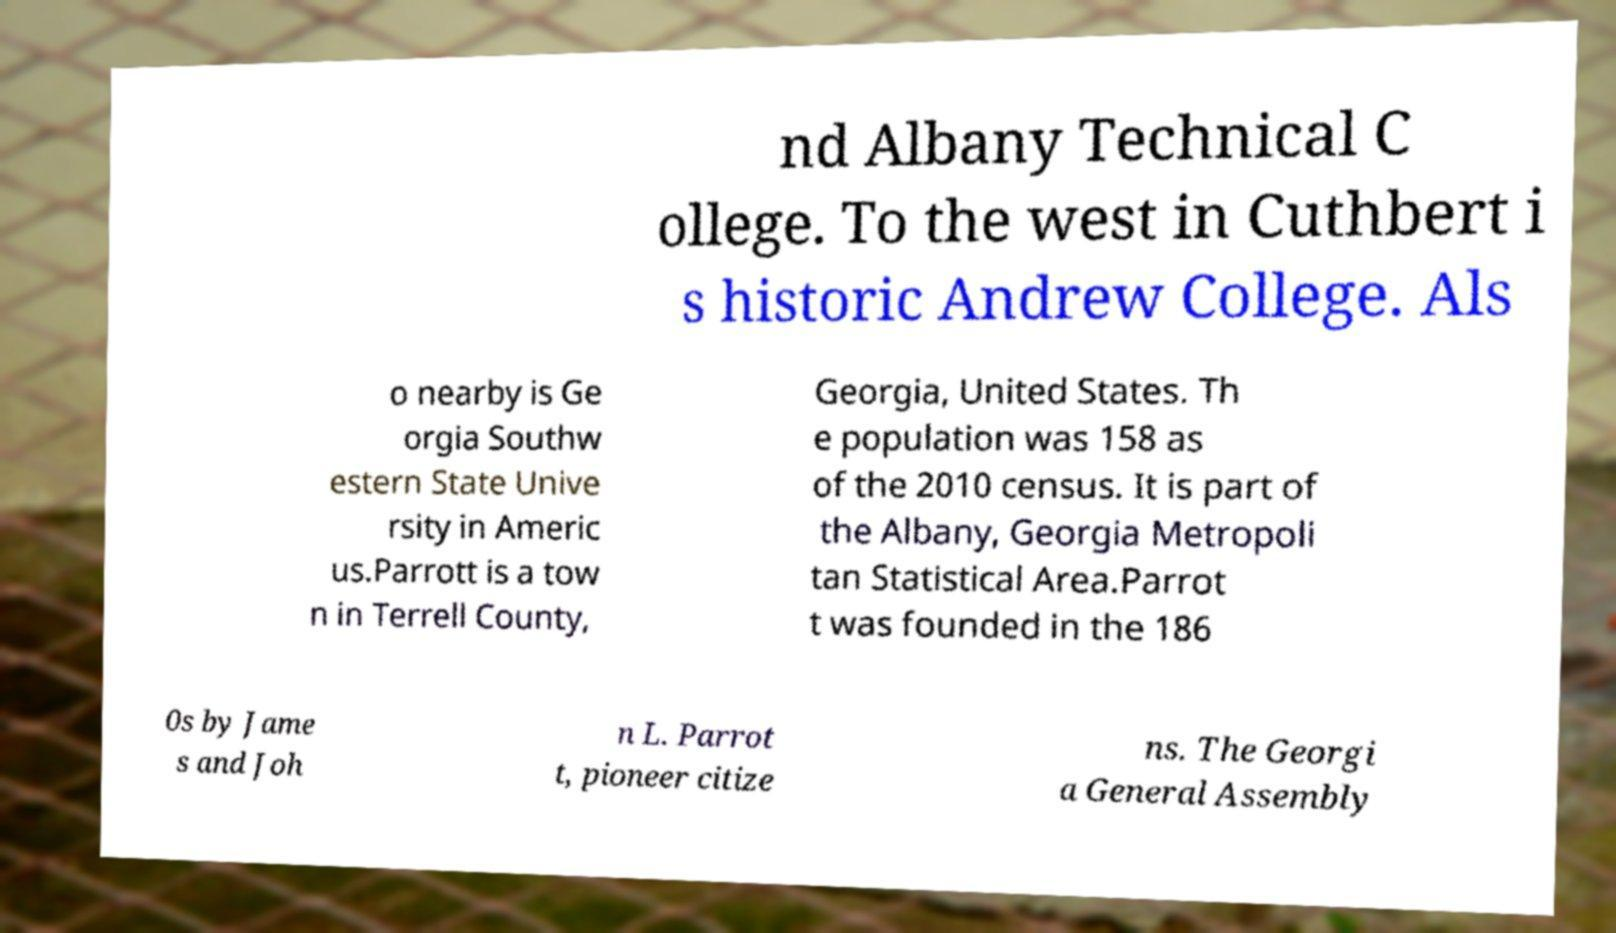What messages or text are displayed in this image? I need them in a readable, typed format. nd Albany Technical C ollege. To the west in Cuthbert i s historic Andrew College. Als o nearby is Ge orgia Southw estern State Unive rsity in Americ us.Parrott is a tow n in Terrell County, Georgia, United States. Th e population was 158 as of the 2010 census. It is part of the Albany, Georgia Metropoli tan Statistical Area.Parrot t was founded in the 186 0s by Jame s and Joh n L. Parrot t, pioneer citize ns. The Georgi a General Assembly 